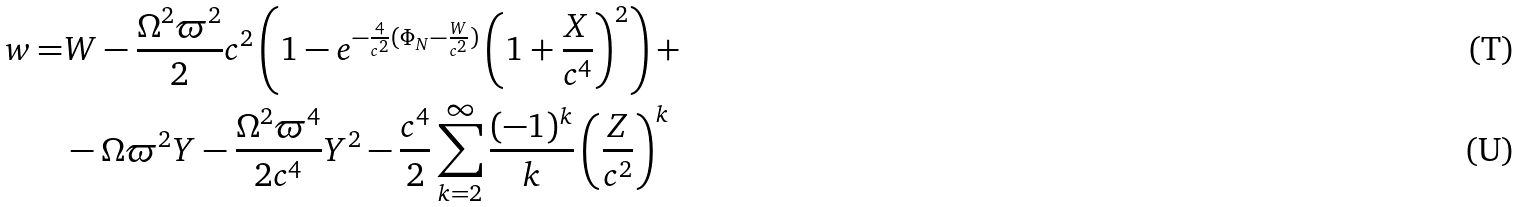<formula> <loc_0><loc_0><loc_500><loc_500>w = & W - \frac { \Omega ^ { 2 } \varpi ^ { 2 } } { 2 } c ^ { 2 } \left ( 1 - e ^ { - \frac { 4 } { c ^ { 2 } } ( \Phi _ { N } - \frac { W } { c ^ { 2 } } ) } \left ( 1 + \frac { X } { c ^ { 4 } } \right ) ^ { 2 } \right ) + \\ & - \Omega \varpi ^ { 2 } Y - \frac { \Omega ^ { 2 } \varpi ^ { 4 } } { 2 c ^ { 4 } } Y ^ { 2 } - \frac { c ^ { 4 } } { 2 } \sum _ { k = 2 } ^ { \infty } \frac { ( - 1 ) ^ { k } } { k } \left ( \frac { Z } { c ^ { 2 } } \right ) ^ { k }</formula> 